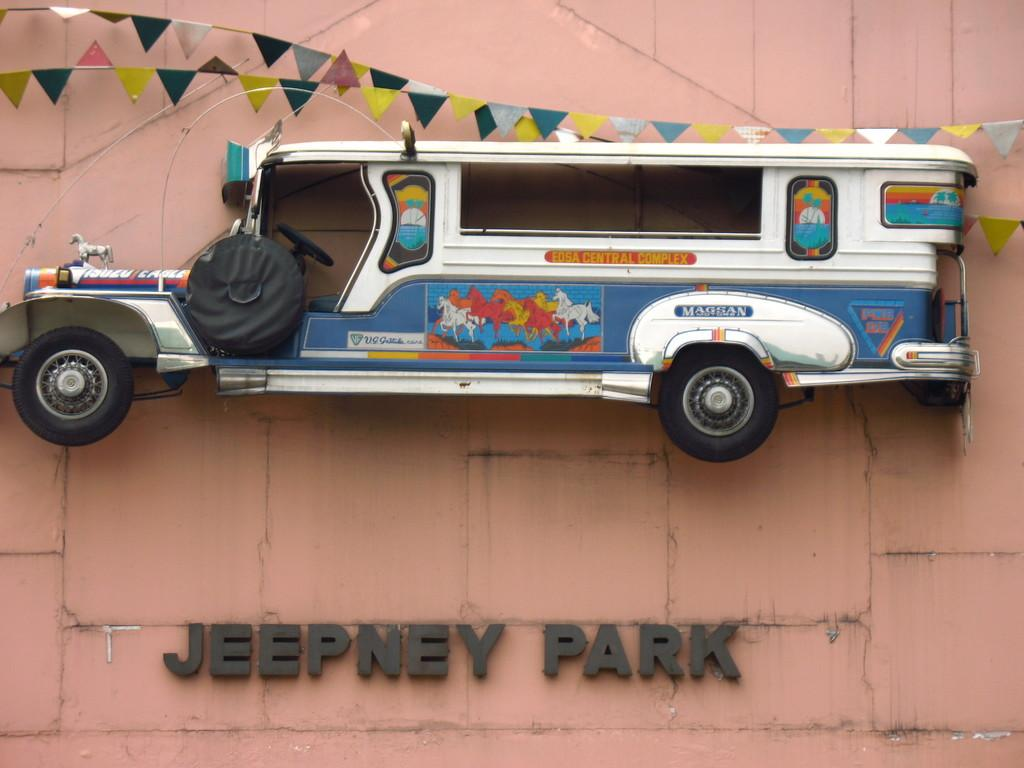What is one of the main features in the image? There is a wall in the image. What object can be seen on the ground in the image? There is a toy car in the image. What advertisement can be seen on the wall in the image? There is no advertisement present on the wall in the image. Is there a note left by the child's brother in the image? There is no mention of a child or a brother in the image, so it cannot be determined if there is a note left by the brother. 